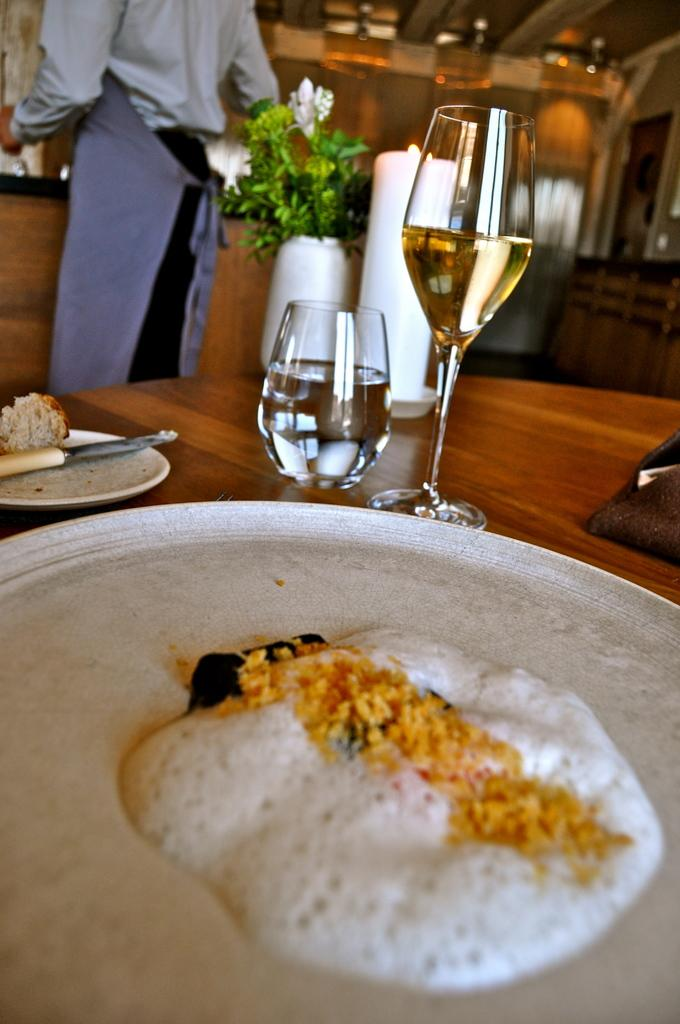What is present in the tray that is visible in the image? There is food in the tray in the image. What type of dish is also visible in the image? There is a plate in the image. What utensil is being used with the food in the image? There is a knife with some food in the image. What type of container is present for holding liquids in the image? There are glasses in the image. What type of decorative item can be seen on the table in the image? There is a flower pot on the table in the image. Who is present in the image? There is a man standing in the image. What type of insurance policy is being discussed in the image? There is no mention of insurance or any discussion in the image; it primarily features food, utensils, and a man standing. How many beads are visible in the image? There are no beads present in the image. 